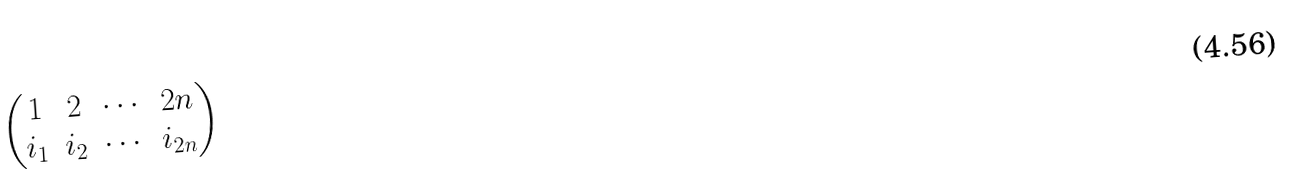<formula> <loc_0><loc_0><loc_500><loc_500>\begin{pmatrix} 1 & 2 & \cdots & 2 n \\ i _ { 1 } & i _ { 2 } & \cdots & i _ { 2 n } \end{pmatrix}</formula> 